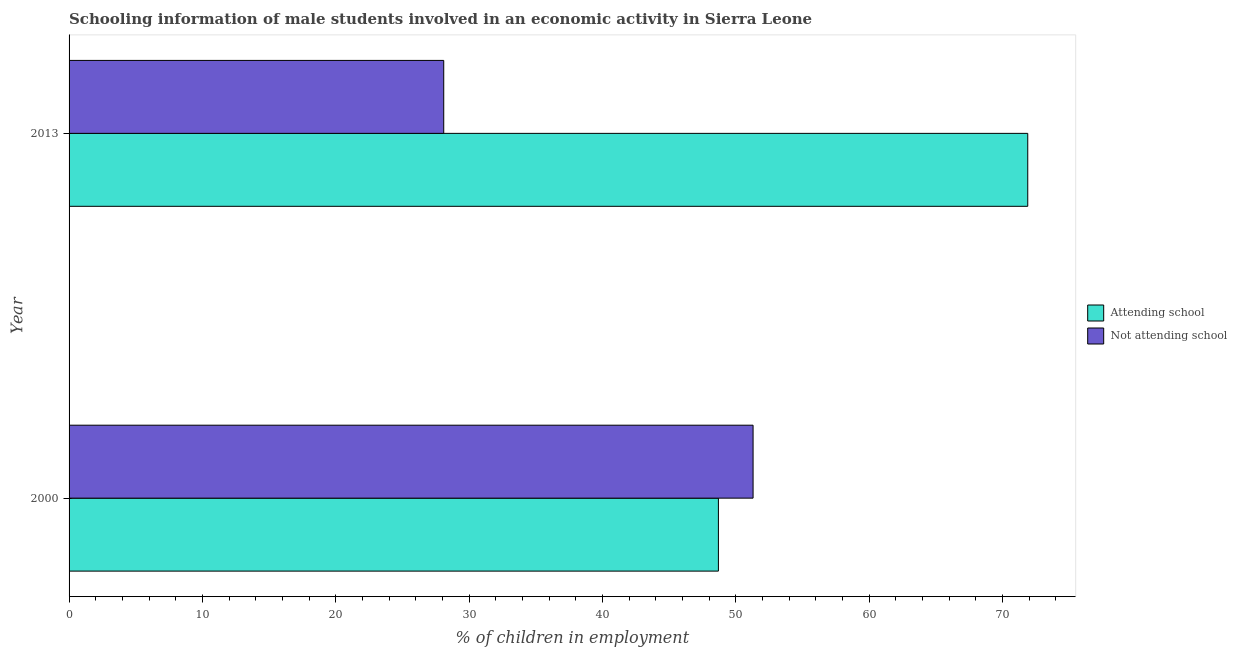How many different coloured bars are there?
Provide a succinct answer. 2. How many groups of bars are there?
Give a very brief answer. 2. Are the number of bars on each tick of the Y-axis equal?
Ensure brevity in your answer.  Yes. How many bars are there on the 1st tick from the bottom?
Ensure brevity in your answer.  2. What is the percentage of employed males who are attending school in 2000?
Provide a short and direct response. 48.7. Across all years, what is the maximum percentage of employed males who are not attending school?
Your answer should be very brief. 51.3. Across all years, what is the minimum percentage of employed males who are not attending school?
Make the answer very short. 28.1. In which year was the percentage of employed males who are attending school minimum?
Provide a succinct answer. 2000. What is the total percentage of employed males who are attending school in the graph?
Offer a very short reply. 120.6. What is the difference between the percentage of employed males who are attending school in 2000 and that in 2013?
Your answer should be compact. -23.2. What is the difference between the percentage of employed males who are attending school in 2000 and the percentage of employed males who are not attending school in 2013?
Keep it short and to the point. 20.6. What is the average percentage of employed males who are not attending school per year?
Provide a succinct answer. 39.7. In how many years, is the percentage of employed males who are attending school greater than 48 %?
Provide a short and direct response. 2. What is the ratio of the percentage of employed males who are attending school in 2000 to that in 2013?
Keep it short and to the point. 0.68. Is the percentage of employed males who are not attending school in 2000 less than that in 2013?
Your answer should be very brief. No. Is the difference between the percentage of employed males who are not attending school in 2000 and 2013 greater than the difference between the percentage of employed males who are attending school in 2000 and 2013?
Your answer should be very brief. Yes. What does the 1st bar from the top in 2000 represents?
Keep it short and to the point. Not attending school. What does the 2nd bar from the bottom in 2013 represents?
Your response must be concise. Not attending school. Does the graph contain grids?
Provide a succinct answer. No. Where does the legend appear in the graph?
Ensure brevity in your answer.  Center right. What is the title of the graph?
Your response must be concise. Schooling information of male students involved in an economic activity in Sierra Leone. What is the label or title of the X-axis?
Ensure brevity in your answer.  % of children in employment. What is the label or title of the Y-axis?
Provide a succinct answer. Year. What is the % of children in employment of Attending school in 2000?
Ensure brevity in your answer.  48.7. What is the % of children in employment in Not attending school in 2000?
Keep it short and to the point. 51.3. What is the % of children in employment in Attending school in 2013?
Offer a terse response. 71.9. What is the % of children in employment of Not attending school in 2013?
Your answer should be compact. 28.1. Across all years, what is the maximum % of children in employment of Attending school?
Offer a very short reply. 71.9. Across all years, what is the maximum % of children in employment of Not attending school?
Give a very brief answer. 51.3. Across all years, what is the minimum % of children in employment of Attending school?
Make the answer very short. 48.7. Across all years, what is the minimum % of children in employment of Not attending school?
Offer a terse response. 28.1. What is the total % of children in employment of Attending school in the graph?
Ensure brevity in your answer.  120.6. What is the total % of children in employment in Not attending school in the graph?
Offer a terse response. 79.4. What is the difference between the % of children in employment in Attending school in 2000 and that in 2013?
Your answer should be very brief. -23.2. What is the difference between the % of children in employment in Not attending school in 2000 and that in 2013?
Ensure brevity in your answer.  23.2. What is the difference between the % of children in employment of Attending school in 2000 and the % of children in employment of Not attending school in 2013?
Your response must be concise. 20.6. What is the average % of children in employment of Attending school per year?
Your answer should be very brief. 60.3. What is the average % of children in employment of Not attending school per year?
Your answer should be compact. 39.7. In the year 2000, what is the difference between the % of children in employment of Attending school and % of children in employment of Not attending school?
Your response must be concise. -2.6. In the year 2013, what is the difference between the % of children in employment in Attending school and % of children in employment in Not attending school?
Provide a succinct answer. 43.8. What is the ratio of the % of children in employment in Attending school in 2000 to that in 2013?
Offer a terse response. 0.68. What is the ratio of the % of children in employment in Not attending school in 2000 to that in 2013?
Provide a short and direct response. 1.83. What is the difference between the highest and the second highest % of children in employment in Attending school?
Make the answer very short. 23.2. What is the difference between the highest and the second highest % of children in employment of Not attending school?
Your answer should be compact. 23.2. What is the difference between the highest and the lowest % of children in employment in Attending school?
Give a very brief answer. 23.2. What is the difference between the highest and the lowest % of children in employment in Not attending school?
Give a very brief answer. 23.2. 